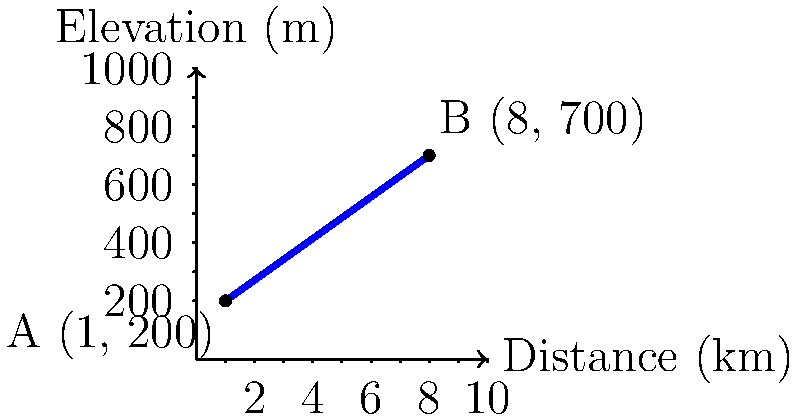A battalion is moving from point A to point B across hilly terrain. Point A is located at coordinates (1 km, 200 m) and point B is at (8 km, 700 m), where the first coordinate represents the horizontal distance traveled and the second represents the elevation. Calculate the slope of the line representing the troop movement, which indicates the rate of elevation gain per kilometer traveled. Express your answer as a decimal to two decimal places. To find the slope of the line representing troop movement, we'll use the slope formula:

$$ \text{Slope} = \frac{\text{Change in y}}{\text{Change in x}} = \frac{y_2 - y_1}{x_2 - x_1} $$

1) Identify the coordinates:
   Point A: $(x_1, y_1) = (1, 200)$
   Point B: $(x_2, y_2) = (8, 700)$

2) Calculate the change in y (elevation):
   $\Delta y = y_2 - y_1 = 700 - 200 = 500$ meters

3) Calculate the change in x (horizontal distance):
   $\Delta x = x_2 - x_1 = 8 - 1 = 7$ kilometers

4) Apply the slope formula:
   $$ \text{Slope} = \frac{500 \text{ m}}{7 \text{ km}} $$

5) Convert meters to kilometers for consistency:
   $$ \text{Slope} = \frac{0.5 \text{ km}}{7 \text{ km}} = \frac{1}{14} \approx 0.0714 $$

6) Round to two decimal places:
   $$ \text{Slope} \approx 0.07 $$

This means the troops are gaining approximately 0.07 km (70 m) in elevation for every 1 km traveled horizontally.
Answer: 0.07 